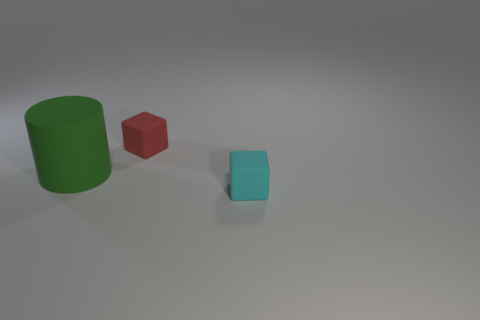Subtract all cyan blocks. How many blocks are left? 1 Subtract 0 blue spheres. How many objects are left? 3 Subtract all cylinders. How many objects are left? 2 Subtract all purple cylinders. Subtract all blue spheres. How many cylinders are left? 1 Subtract all blue balls. How many red blocks are left? 1 Subtract all small red metallic cylinders. Subtract all cyan rubber blocks. How many objects are left? 2 Add 1 small rubber objects. How many small rubber objects are left? 3 Add 3 small red objects. How many small red objects exist? 4 Add 1 cyan matte objects. How many objects exist? 4 